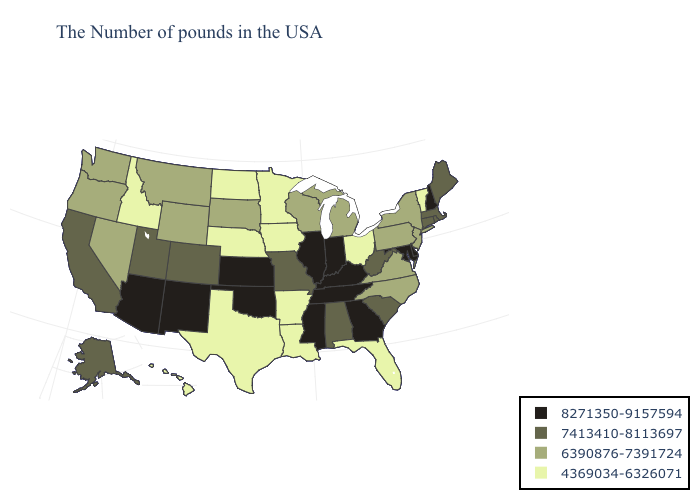What is the lowest value in states that border Wisconsin?
Quick response, please. 4369034-6326071. What is the value of Ohio?
Give a very brief answer. 4369034-6326071. Among the states that border Indiana , does Illinois have the lowest value?
Keep it brief. No. Does Minnesota have the lowest value in the MidWest?
Short answer required. Yes. What is the value of Virginia?
Answer briefly. 6390876-7391724. Does Tennessee have the highest value in the South?
Answer briefly. Yes. What is the highest value in states that border Illinois?
Quick response, please. 8271350-9157594. What is the value of Tennessee?
Short answer required. 8271350-9157594. Name the states that have a value in the range 7413410-8113697?
Answer briefly. Maine, Massachusetts, Rhode Island, Connecticut, South Carolina, West Virginia, Alabama, Missouri, Colorado, Utah, California, Alaska. What is the value of Arkansas?
Write a very short answer. 4369034-6326071. Does Florida have the lowest value in the South?
Quick response, please. Yes. Among the states that border Maine , which have the highest value?
Short answer required. New Hampshire. What is the lowest value in states that border Vermont?
Short answer required. 6390876-7391724. Which states hav the highest value in the MidWest?
Short answer required. Indiana, Illinois, Kansas. Does West Virginia have the same value as Alaska?
Be succinct. Yes. 